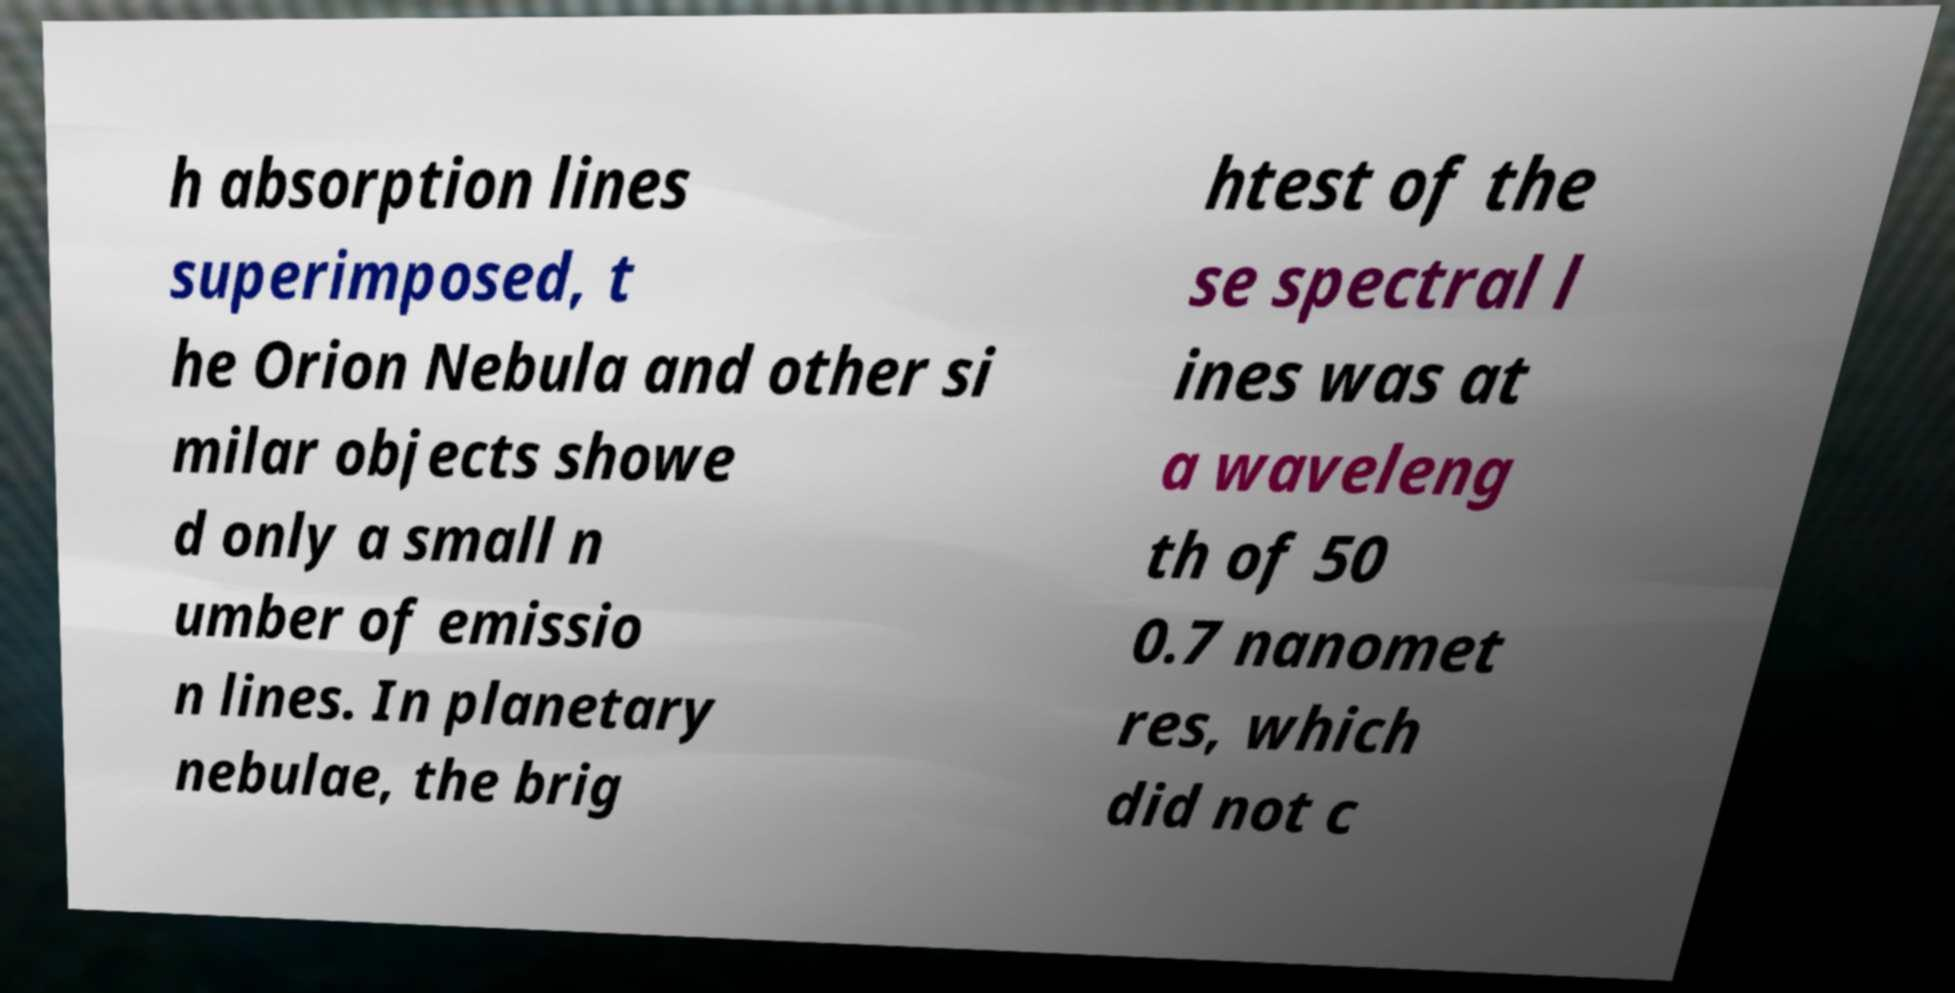What messages or text are displayed in this image? I need them in a readable, typed format. h absorption lines superimposed, t he Orion Nebula and other si milar objects showe d only a small n umber of emissio n lines. In planetary nebulae, the brig htest of the se spectral l ines was at a waveleng th of 50 0.7 nanomet res, which did not c 